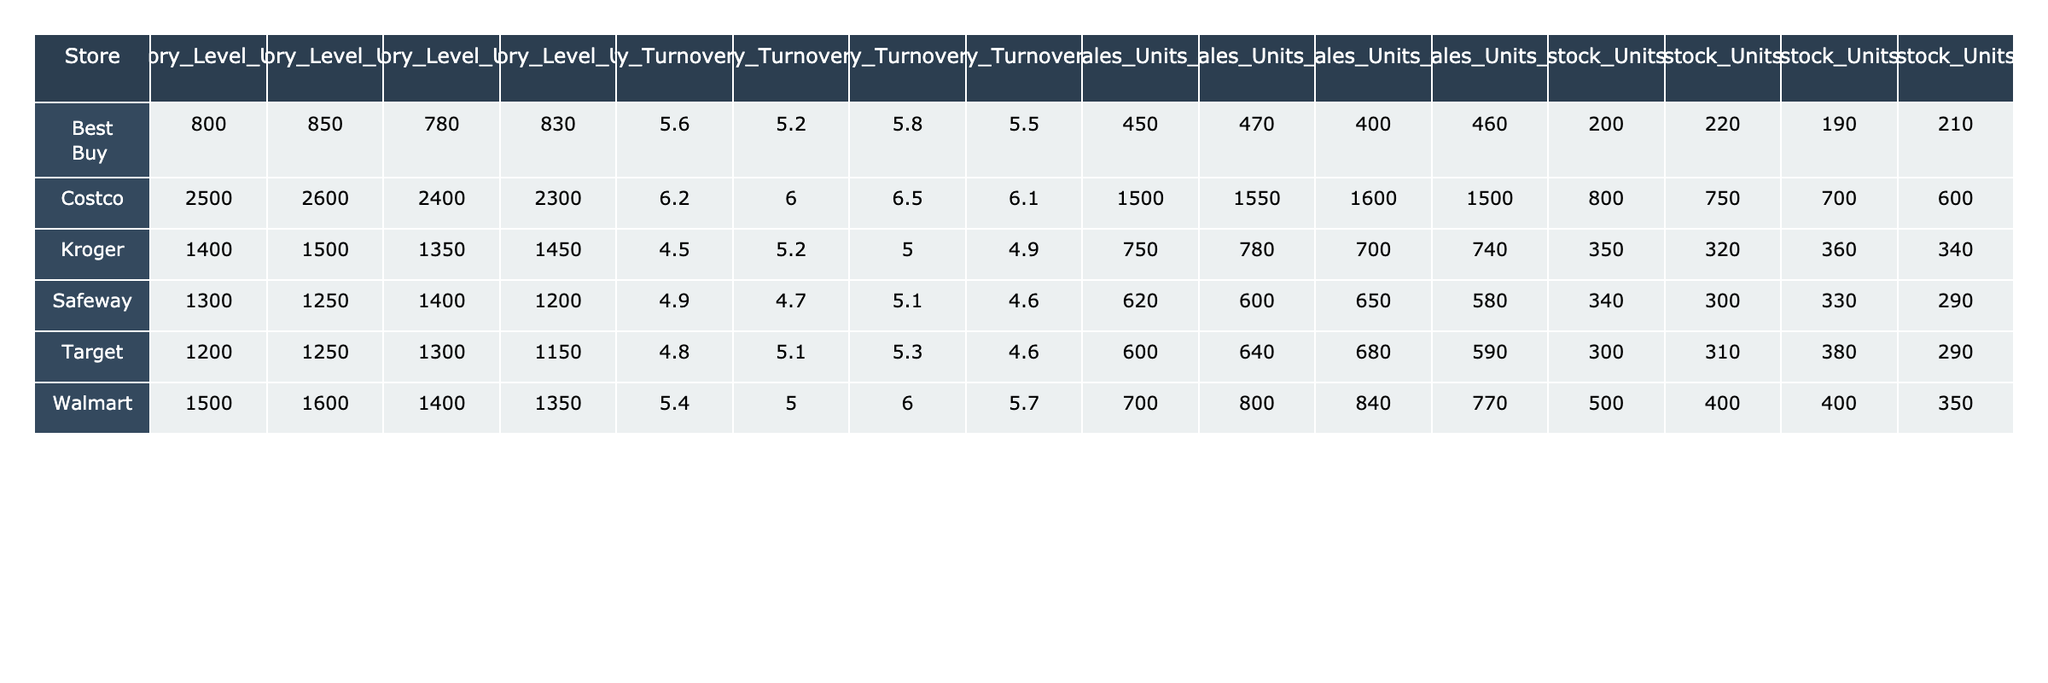What are the inventory levels for Walmart in week 3? Looking at the table, I find the "Inventory_Level_Units_W3" column under "Walmart," which shows the value of 1400.
Answer: 1400 What is the inventory turnover rate for Target in week 4? In the table, the "Inventory_Turnover_Rate_W4" column shows the turnover rate for Target in week 4 is 4.6.
Answer: 4.6 Which store had the highest inventory level in week 2? I compare the "Inventory_Level_Units_W2" values across all stores. Costco has the highest value of 2600.
Answer: Costco What is the total sales units for Kroger over the four weeks? I sum the sales units for Kroger: 750 + 780 + 700 + 740 = 2970.
Answer: 2970 Does Safeway have a higher inventory turnover rate in week 3 than Best Buy in week 4? Comparing "Inventory_Turnover_Rate_W3" for Safeway (5.1) and "Inventory_Turnover_Rate_W4" for Best Buy (5.5), the statement is false because Best Buy has a higher rate.
Answer: False What is the average inventory turnover rate for all stores in week 1? I first find the turnover rates for all stores in week 1: Walmart (5.4), Target (4.8), Costco (6.2), Kroger (4.5), Safeway (4.9), Best Buy (5.6). The average is (5.4 + 4.8 + 6.2 + 4.5 + 4.9 + 5.6) / 6 = 5.3.
Answer: 5.3 In week 4, which store had the lowest sales units? By looking at the "Sales_Units_W4" column, I see that Safeway has the lowest value of 580.
Answer: Safeway What is the difference in inventory levels between Costco and Target for week 3? I look at "Inventory_Level_Units_W3": Costco has 2400, Target has 1300. The difference is 2400 - 1300 = 1100.
Answer: 1100 For which week did Best Buy have the highest inventory turnover rate? I review the "Inventory_Turnover_Rate" columns for Best Buy: W1 (5.6), W2 (5.2), W3 (5.8), W4 (5.5). The highest is in week 3 with 5.8.
Answer: Week 3 What is the total restock units for Walmart over the four weeks? I find the restock units for Walmart: 500 + 400 + 400 + 350 = 1650.
Answer: 1650 